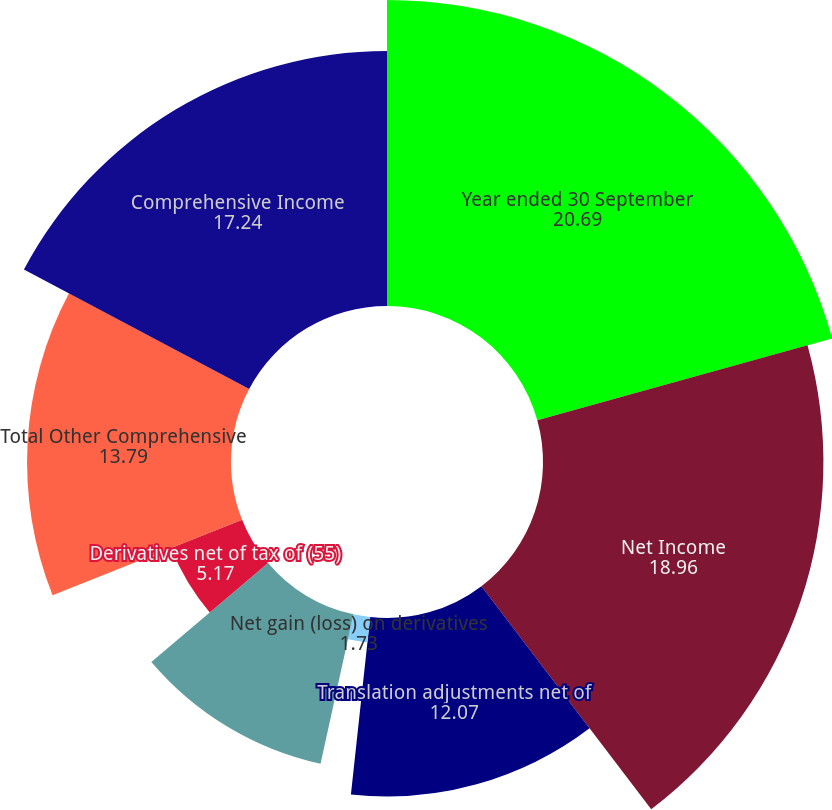Convert chart to OTSL. <chart><loc_0><loc_0><loc_500><loc_500><pie_chart><fcel>Year ended 30 September<fcel>Net Income<fcel>Translation adjustments net of<fcel>Net gain (loss) on derivatives<fcel>Pension and postretirement<fcel>Currency translation<fcel>Derivatives net of tax of (55)<fcel>Total Other Comprehensive<fcel>Comprehensive Income<nl><fcel>20.69%<fcel>18.96%<fcel>12.07%<fcel>1.73%<fcel>10.35%<fcel>0.0%<fcel>5.17%<fcel>13.79%<fcel>17.24%<nl></chart> 